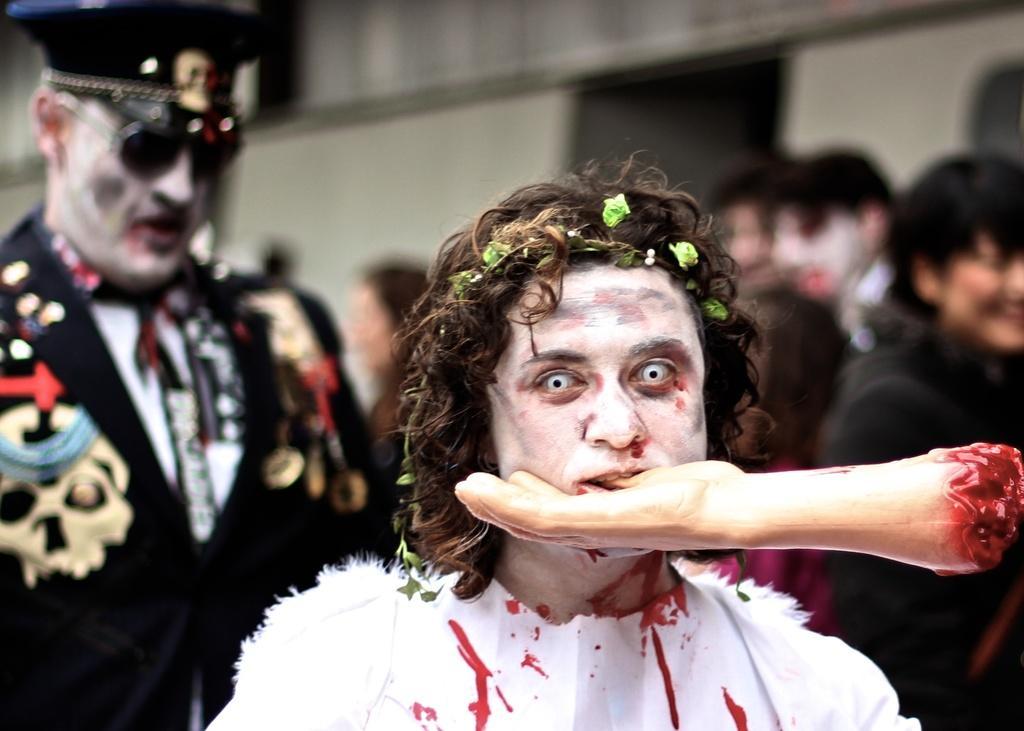How would you summarize this image in a sentence or two? In the middle a person is biting a doll's hand, this person wore a white color dress. In the left side there is a man who wore black color coat, spectacles, cap. In the right side there are few other people. 